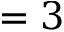Convert formula to latex. <formula><loc_0><loc_0><loc_500><loc_500>= 3</formula> 